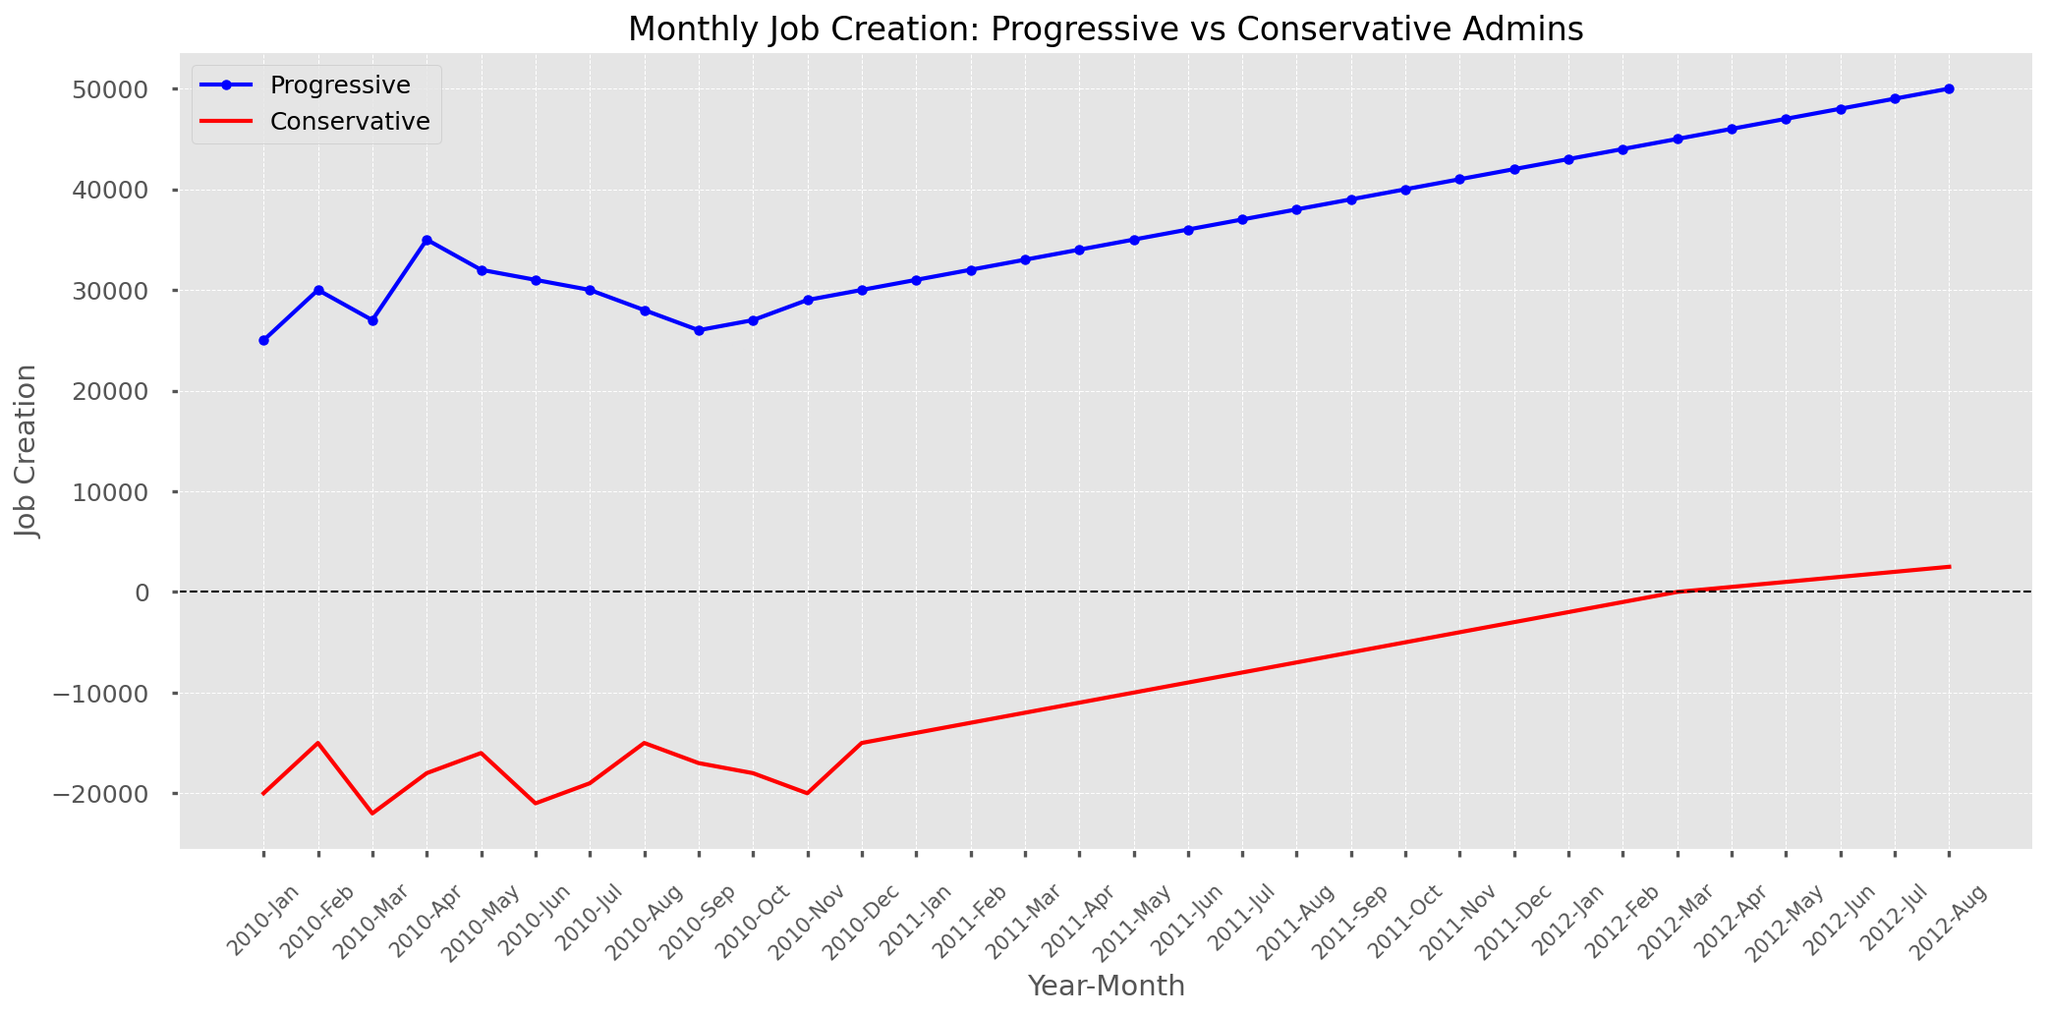When did the Progressive administration first surpass 40,000 jobs created in a month? The Progressive line reaches 40,000 jobs created in October 2011, as indicated by the label on the x-axis and the corresponding intersection with the y-axis value.
Answer: October 2011 How many consecutive months did the Conservative administration have negative job growth in 2010? In 2010, the job creation under the Conservative administration is negative (below the horizontal line at 0) for the entire year. Counting from January to December, it's a total of 12 months.
Answer: 12 months What is the difference in job creation between the Progressive and Conservative administrations in June 2010? In June 2010, Progressive job creation is 31,000, and Conservative job creation is -21,000. The difference is calculated as 31,000 - (-21,000) = 31,000 + 21,000 = 52,000.
Answer: 52,000 Which administration had a job creation figure closest to zero and in which month? The Conservative administration had a job creation figure closest to zero in March 2012, with a value of 0, as indicated by the red line intersecting the x-axis.
Answer: Conservative, March 2012 Compare the job creation trends for both administrations from January 2011 to December 2011. Who had a consistently increasing trend? The Progressive administration shows a consistently increasing trend throughout 2011, with each month's job creation figure higher than the previous one, starting from 31,000 in January to 42,000 in December. The Conservative administration also shows an increasing trend but stays negative until the very end of 2011.
Answer: Progressive What is the range of job creation values for the Conservative administration in 2011? The job creation values for the Conservative administration in 2011 range from -14,000 in January to -3,000 in December. The range is calculated as -3,000 - (-14,000) = 11,000.
Answer: 11,000 In which year and month did both administrations have positive job creation figures for the first time? The first instance where both administrations have positive job creation figures happens in April 2012; the Progressive administration has 46,000 jobs created, and the Conservative administration has 500.
Answer: April 2012 How does the job creation trend for the Conservative administration compare before and after March 2012? Before March 2012, the Conservative administration has negative or zero job creation. After March 2012, the job creation figures are positive and increase gradually each month, starting from 500 in April 2012.
Answer: Turning positive and increasing What is the average job creation for the Progressive administration in 2011? In 2011, the Progressive administration's job creation values are 31,000, 32,000, 33,000, 34,000, 35,000, 36,000, 37,000, 38,000, 39,000, 40,000, 41,000, and 42,000. The sum is 438,000. The average is 438,000 / 12 = 36,500.
Answer: 36,500 At which point do the job creation lines for Progressive and Conservative administrations intersect with the zero line? The Progressive administration never intersects with the zero line as it's always positive. The Conservative administration intersects with the zero line in March 2012, indicating a job creation figure of 0.
Answer: Conservative, March 2012 